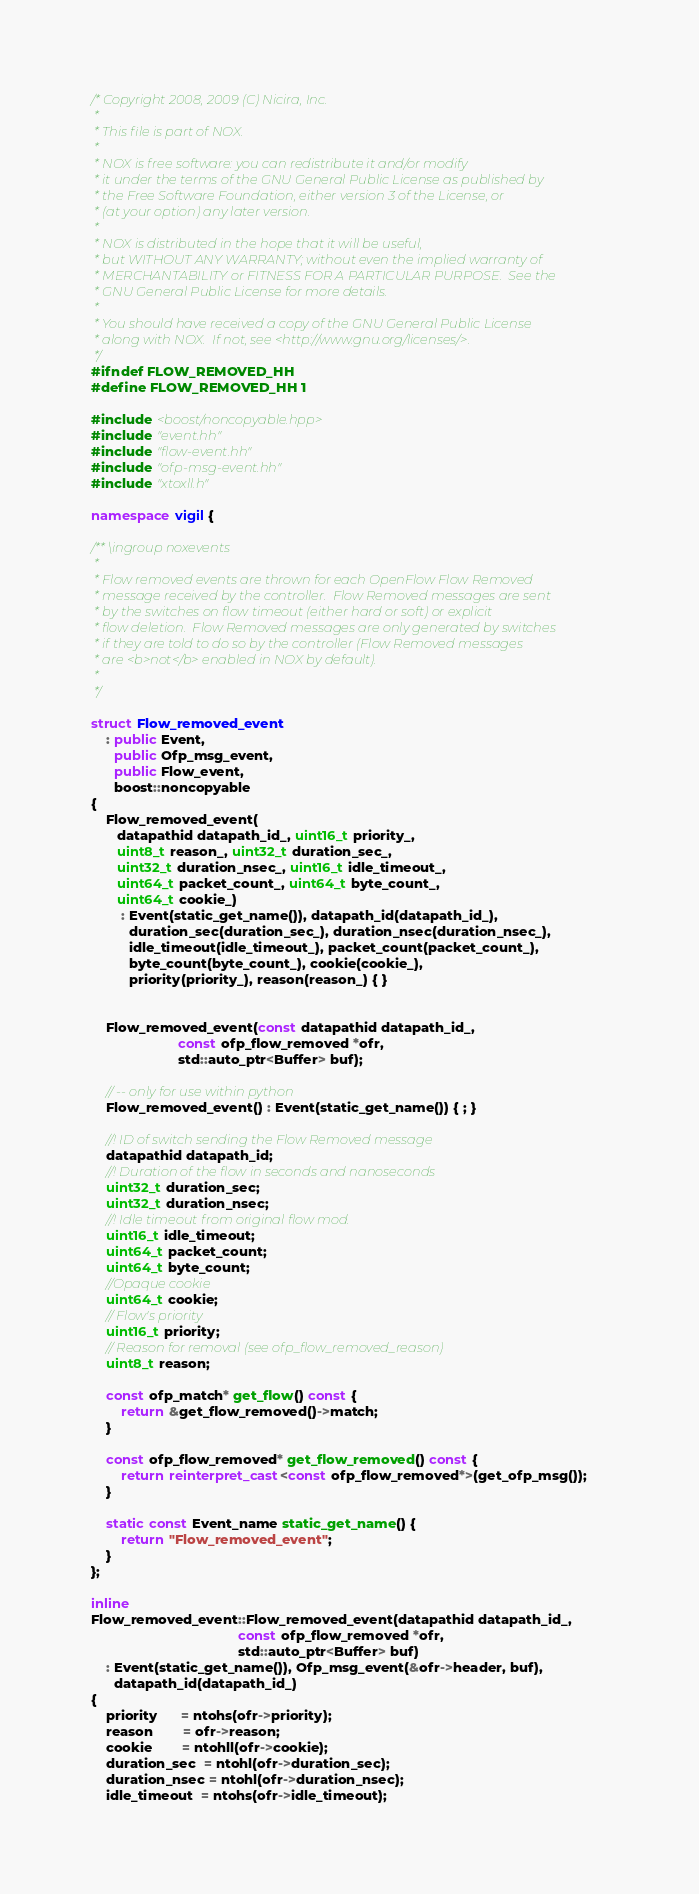Convert code to text. <code><loc_0><loc_0><loc_500><loc_500><_C++_>/* Copyright 2008, 2009 (C) Nicira, Inc.
 *
 * This file is part of NOX.
 *
 * NOX is free software: you can redistribute it and/or modify
 * it under the terms of the GNU General Public License as published by
 * the Free Software Foundation, either version 3 of the License, or
 * (at your option) any later version.
 *
 * NOX is distributed in the hope that it will be useful,
 * but WITHOUT ANY WARRANTY; without even the implied warranty of
 * MERCHANTABILITY or FITNESS FOR A PARTICULAR PURPOSE.  See the
 * GNU General Public License for more details.
 *
 * You should have received a copy of the GNU General Public License
 * along with NOX.  If not, see <http://www.gnu.org/licenses/>.
 */
#ifndef FLOW_REMOVED_HH
#define FLOW_REMOVED_HH 1

#include <boost/noncopyable.hpp>
#include "event.hh"
#include "flow-event.hh"
#include "ofp-msg-event.hh"
#include "xtoxll.h"

namespace vigil {

/** \ingroup noxevents
 *
 * Flow removed events are thrown for each OpenFlow Flow Removed 
 * message received by the controller.  Flow Removed messages are sent 
 * by the switches on flow timeout (either hard or soft) or explicit
 * flow deletion.  Flow Removed messages are only generated by switches 
 * if they are told to do so by the controller (Flow Removed messages 
 * are <b>not</b> enabled in NOX by default).
 *
 */

struct Flow_removed_event
    : public Event,
      public Ofp_msg_event,
      public Flow_event,
      boost::noncopyable
{
    Flow_removed_event(
       datapathid datapath_id_, uint16_t priority_,
       uint8_t reason_, uint32_t duration_sec_,
       uint32_t duration_nsec_, uint16_t idle_timeout_,
       uint64_t packet_count_, uint64_t byte_count_,
       uint64_t cookie_)
        : Event(static_get_name()), datapath_id(datapath_id_),
          duration_sec(duration_sec_), duration_nsec(duration_nsec_),
          idle_timeout(idle_timeout_), packet_count(packet_count_),
          byte_count(byte_count_), cookie(cookie_),
          priority(priority_), reason(reason_) { }


    Flow_removed_event(const datapathid datapath_id_, 
                       const ofp_flow_removed *ofr,
                       std::auto_ptr<Buffer> buf);

    // -- only for use within python
    Flow_removed_event() : Event(static_get_name()) { ; }

    //! ID of switch sending the Flow Removed message 
    datapathid datapath_id;
    //! Duration of the flow in seconds and nanoseconds
    uint32_t duration_sec;
    uint32_t duration_nsec;
    //! Idle timeout from original flow mod.
    uint16_t idle_timeout;
    uint64_t packet_count;
    uint64_t byte_count;
    //Opaque cookie
    uint64_t cookie;
    // Flow's priority
    uint16_t priority;
    // Reason for removal (see ofp_flow_removed_reason)
    uint8_t reason;

    const ofp_match* get_flow() const {
        return &get_flow_removed()->match;
    }

    const ofp_flow_removed* get_flow_removed() const {
        return reinterpret_cast<const ofp_flow_removed*>(get_ofp_msg());
    }

    static const Event_name static_get_name() {
        return "Flow_removed_event";
    }
};

inline
Flow_removed_event::Flow_removed_event(datapathid datapath_id_,
                                       const ofp_flow_removed *ofr,
                                       std::auto_ptr<Buffer> buf)
    : Event(static_get_name()), Ofp_msg_event(&ofr->header, buf),
      datapath_id(datapath_id_)
{
    priority      = ntohs(ofr->priority);
    reason        = ofr->reason;
    cookie        = ntohll(ofr->cookie);
    duration_sec  = ntohl(ofr->duration_sec);
    duration_nsec = ntohl(ofr->duration_nsec);
    idle_timeout  = ntohs(ofr->idle_timeout);</code> 